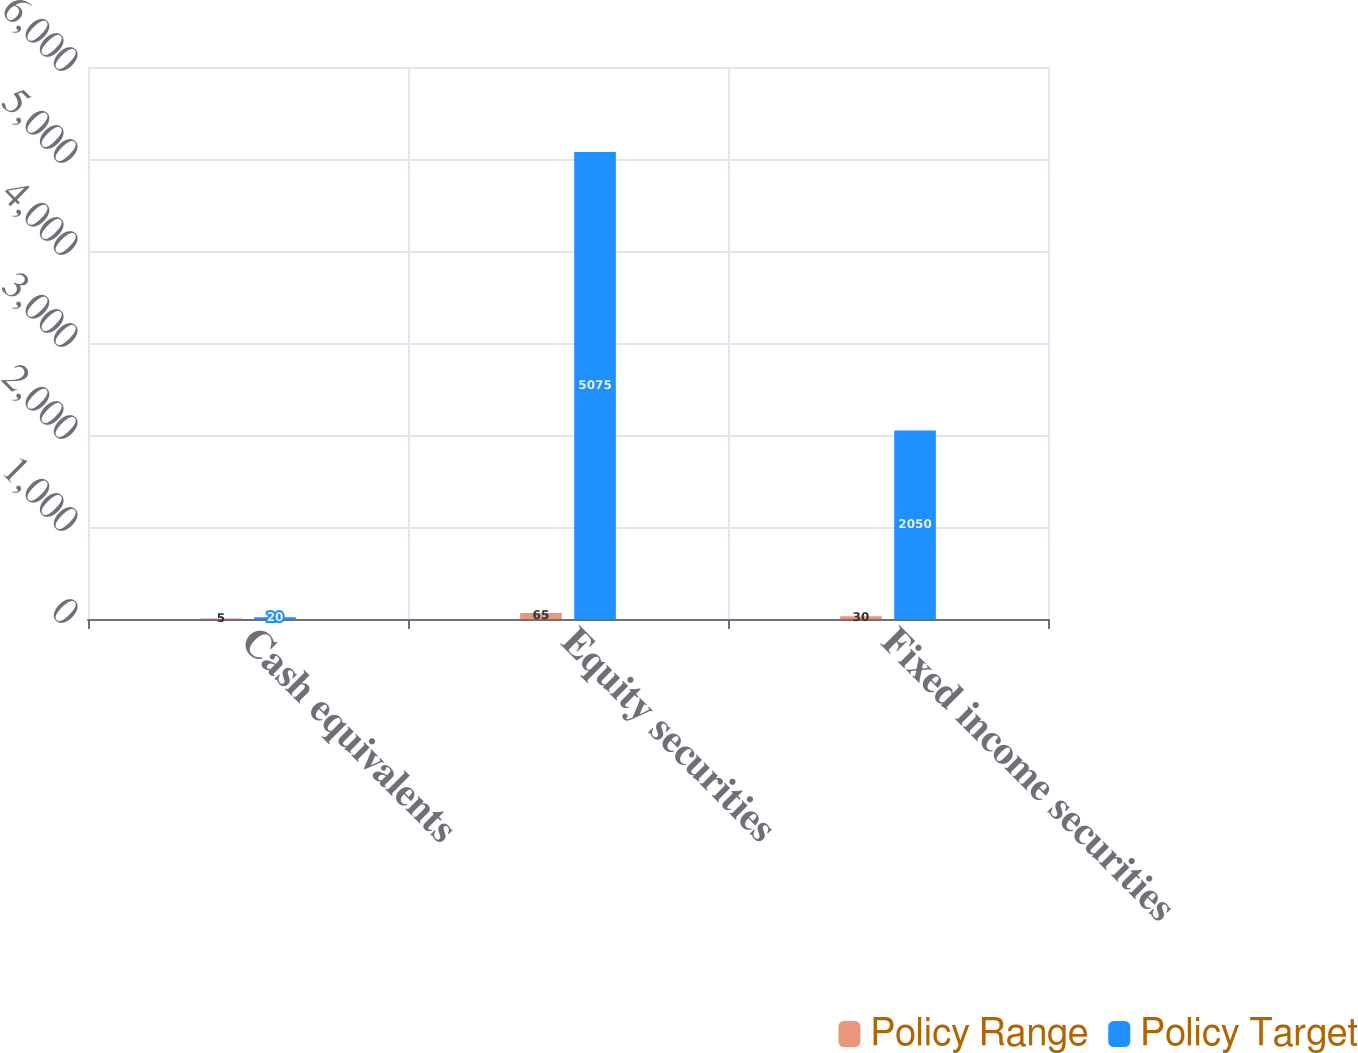Convert chart to OTSL. <chart><loc_0><loc_0><loc_500><loc_500><stacked_bar_chart><ecel><fcel>Cash equivalents<fcel>Equity securities<fcel>Fixed income securities<nl><fcel>Policy Range<fcel>5<fcel>65<fcel>30<nl><fcel>Policy Target<fcel>20<fcel>5075<fcel>2050<nl></chart> 